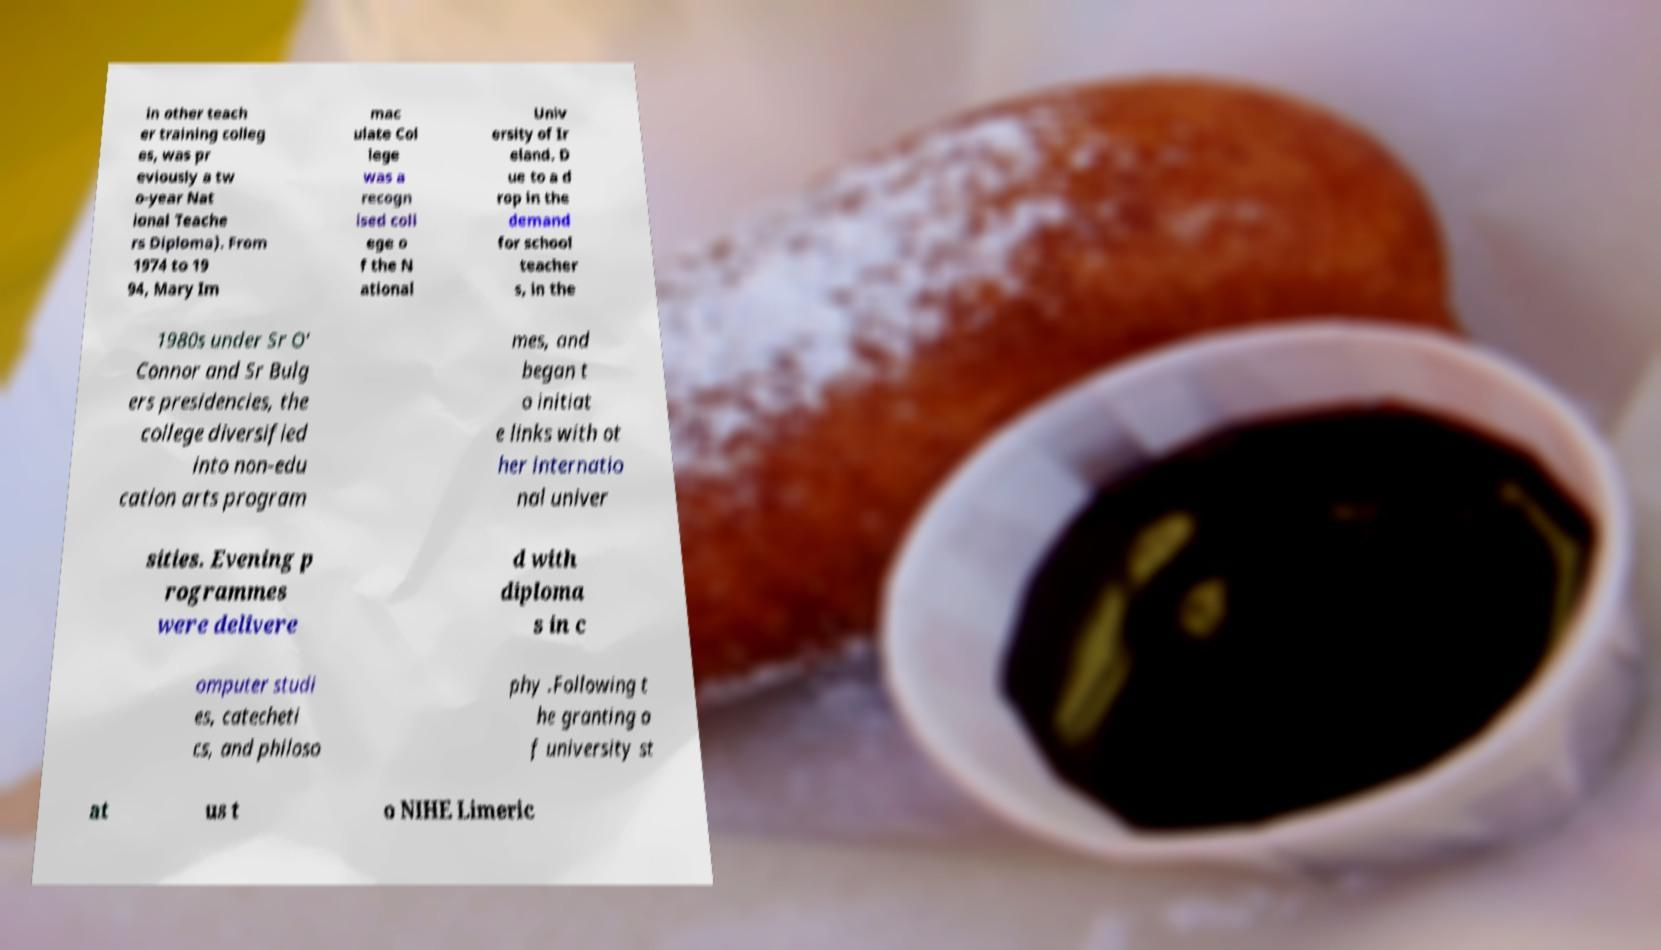Please identify and transcribe the text found in this image. in other teach er training colleg es, was pr eviously a tw o-year Nat ional Teache rs Diploma). From 1974 to 19 94, Mary Im mac ulate Col lege was a recogn ised coll ege o f the N ational Univ ersity of Ir eland. D ue to a d rop in the demand for school teacher s, in the 1980s under Sr O' Connor and Sr Bulg ers presidencies, the college diversified into non-edu cation arts program mes, and began t o initiat e links with ot her internatio nal univer sities. Evening p rogrammes were delivere d with diploma s in c omputer studi es, catecheti cs, and philoso phy .Following t he granting o f university st at us t o NIHE Limeric 